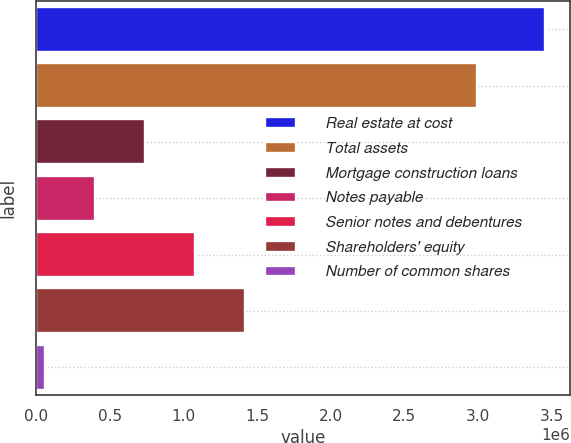Convert chart to OTSL. <chart><loc_0><loc_0><loc_500><loc_500><bar_chart><fcel>Real estate at cost<fcel>Total assets<fcel>Mortgage construction loans<fcel>Notes payable<fcel>Senior notes and debentures<fcel>Shareholders' equity<fcel>Number of common shares<nl><fcel>3.45285e+06<fcel>2.9893e+06<fcel>737486<fcel>398066<fcel>1.07691e+06<fcel>1.41633e+06<fcel>58646<nl></chart> 